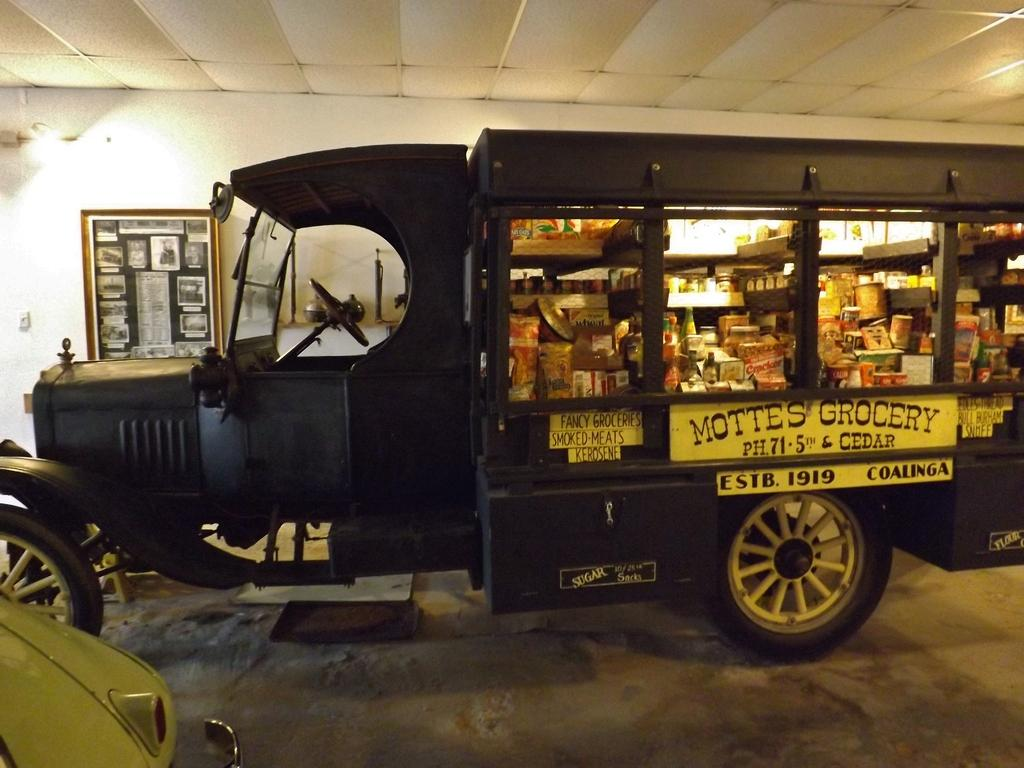Where was the image taken from? The image was taken from inside. What can be seen in the image? There is a vehicle in the image. What is inside the vehicle? There are grocery items inside the vehicle. What can be seen on the wall in the background of the image? There is a photo frame on the wall in the background of the image. How many cats are sitting on the button in the image? There are no cats or buttons present in the image. 